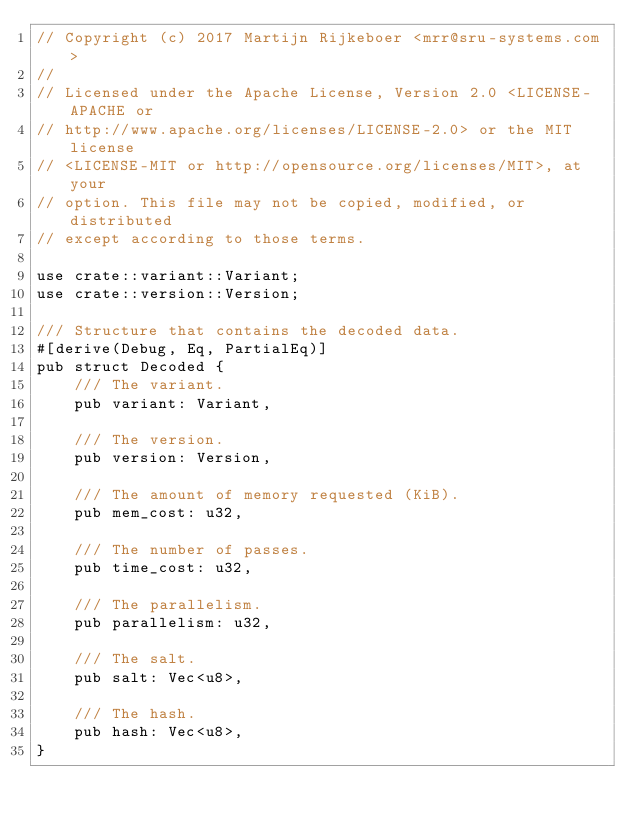<code> <loc_0><loc_0><loc_500><loc_500><_Rust_>// Copyright (c) 2017 Martijn Rijkeboer <mrr@sru-systems.com>
//
// Licensed under the Apache License, Version 2.0 <LICENSE-APACHE or
// http://www.apache.org/licenses/LICENSE-2.0> or the MIT license
// <LICENSE-MIT or http://opensource.org/licenses/MIT>, at your
// option. This file may not be copied, modified, or distributed
// except according to those terms.

use crate::variant::Variant;
use crate::version::Version;

/// Structure that contains the decoded data.
#[derive(Debug, Eq, PartialEq)]
pub struct Decoded {
    /// The variant.
    pub variant: Variant,

    /// The version.
    pub version: Version,

    /// The amount of memory requested (KiB).
    pub mem_cost: u32,

    /// The number of passes.
    pub time_cost: u32,

    /// The parallelism.
    pub parallelism: u32,

    /// The salt.
    pub salt: Vec<u8>,

    /// The hash.
    pub hash: Vec<u8>,
}
</code> 